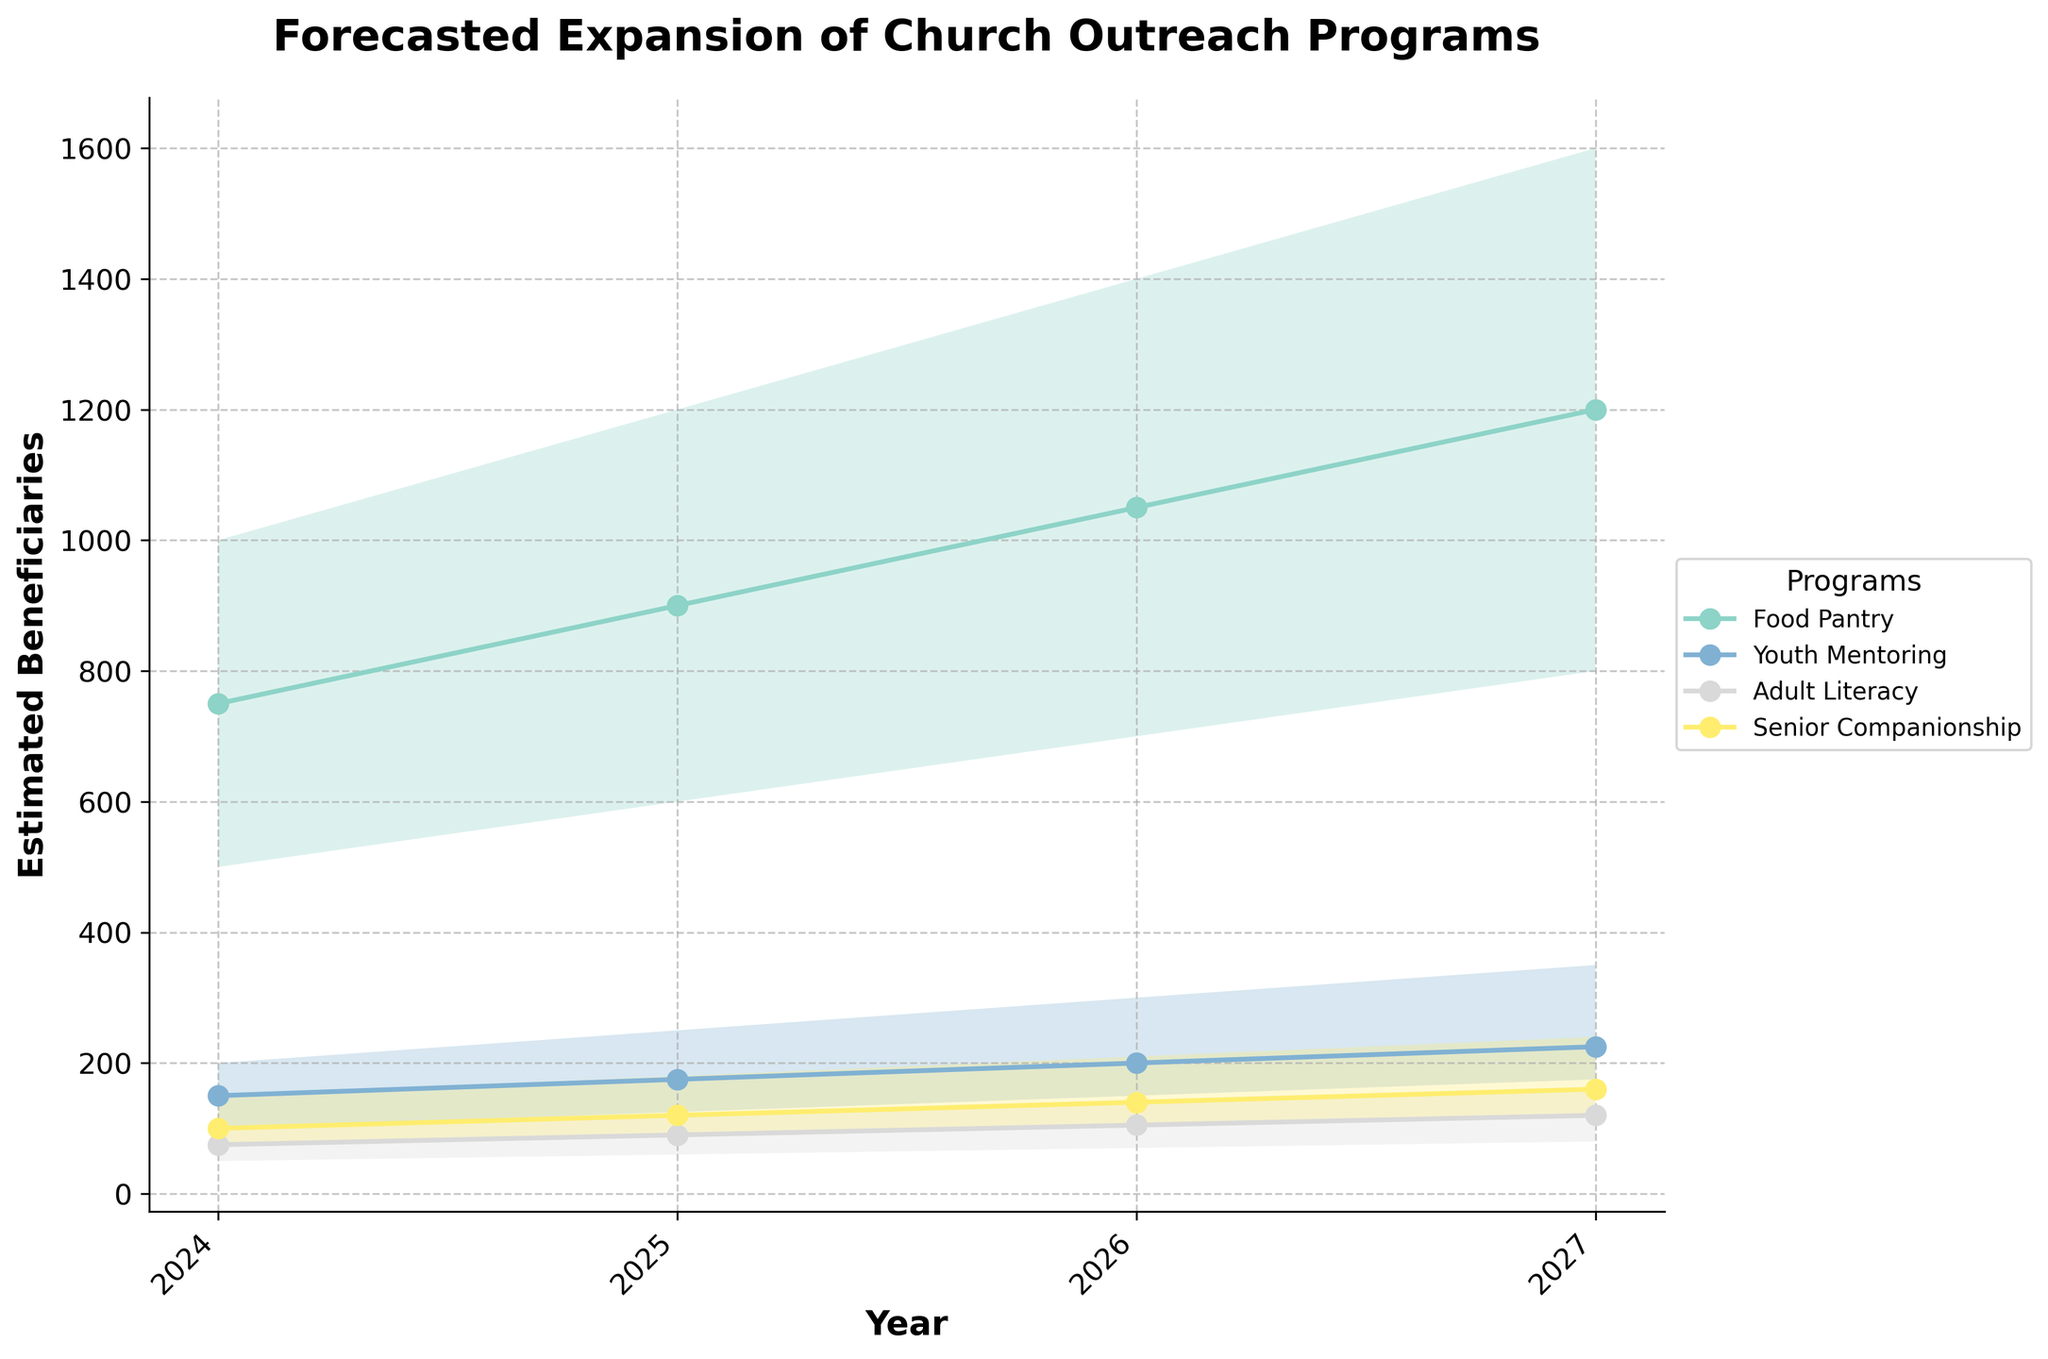what is the title of the chart? The title of the chart is given at the top and it describes the overall subject of the figure. In this case, the title specifies the chart is about forecasted expansion of church outreach programs.
Answer: 'Forecasted Expansion of Church Outreach Programs' How many different programs are forecasted in the chart? By counting the distinct program legends, we can see that the chart forecasts four different programs managed by the church.
Answer: Four What is the expected range of beneficiaries for the Youth Mentoring program in 2025? Locate the shading envelope for the Youth Mentoring program in 2025. The bottom line of the shaded area represents the low estimate, and the top line represents the high estimate. For 2025, this range is from 125 to 250.
Answer: 125 to 250 Which program is forecasted to have the highest number of beneficiaries in 2027? Compare the beneficiaries range for each program in 2027 by looking at the top of the shaded areas. The Food Pantry has the highest upper limit at 1600.
Answer: Food Pantry How does the number of estimated beneficiaries for Adult Literacy change from 2024 to 2026? Track the medium estimate line for the Adult Literacy program from 2024 to 2026. In 2024, the medium estimate is 75, in 2025 it rises to 90, and by 2026 it goes up to 105.
Answer: It increases from 75 to 105 What is the mean of the low estimates for the Senior Companionship in 2024 and 2027? The low estimate for Senior Companionship in 2024 is 75 and in 2027 is 120. Add these values (75 + 120) and divide by 2 to get the mean, which is (75 + 120) / 2.
Answer: 97.5 Which program shows the greatest increase in the high estimate from 2024 to 2027? Compare the high estimates for each program from 2024 to 2027. The Food Pantry shows an increase from 1000 in 2024 to 1600 in 2027, which is the highest increase (600).
Answer: Food Pantry What is the difference between the high and low estimates for the Food Pantry in 2026? Look at the Food Pantry program in 2026 and subtract the low estimate (700) from the high estimate (1400) to find the difference.
Answer: 700 Which two programs have the closest medium estimate values in 2025? Compare the medium estimate values for all programs in 2025. Youth Mentoring and Adult Literacy have the closest values, with 175 and 90 respectively.
Answer: Youth Mentoring and Adult Literacy 